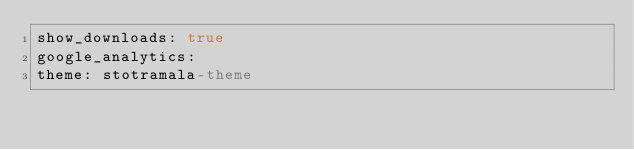<code> <loc_0><loc_0><loc_500><loc_500><_YAML_>show_downloads: true
google_analytics:
theme: stotramala-theme
</code> 